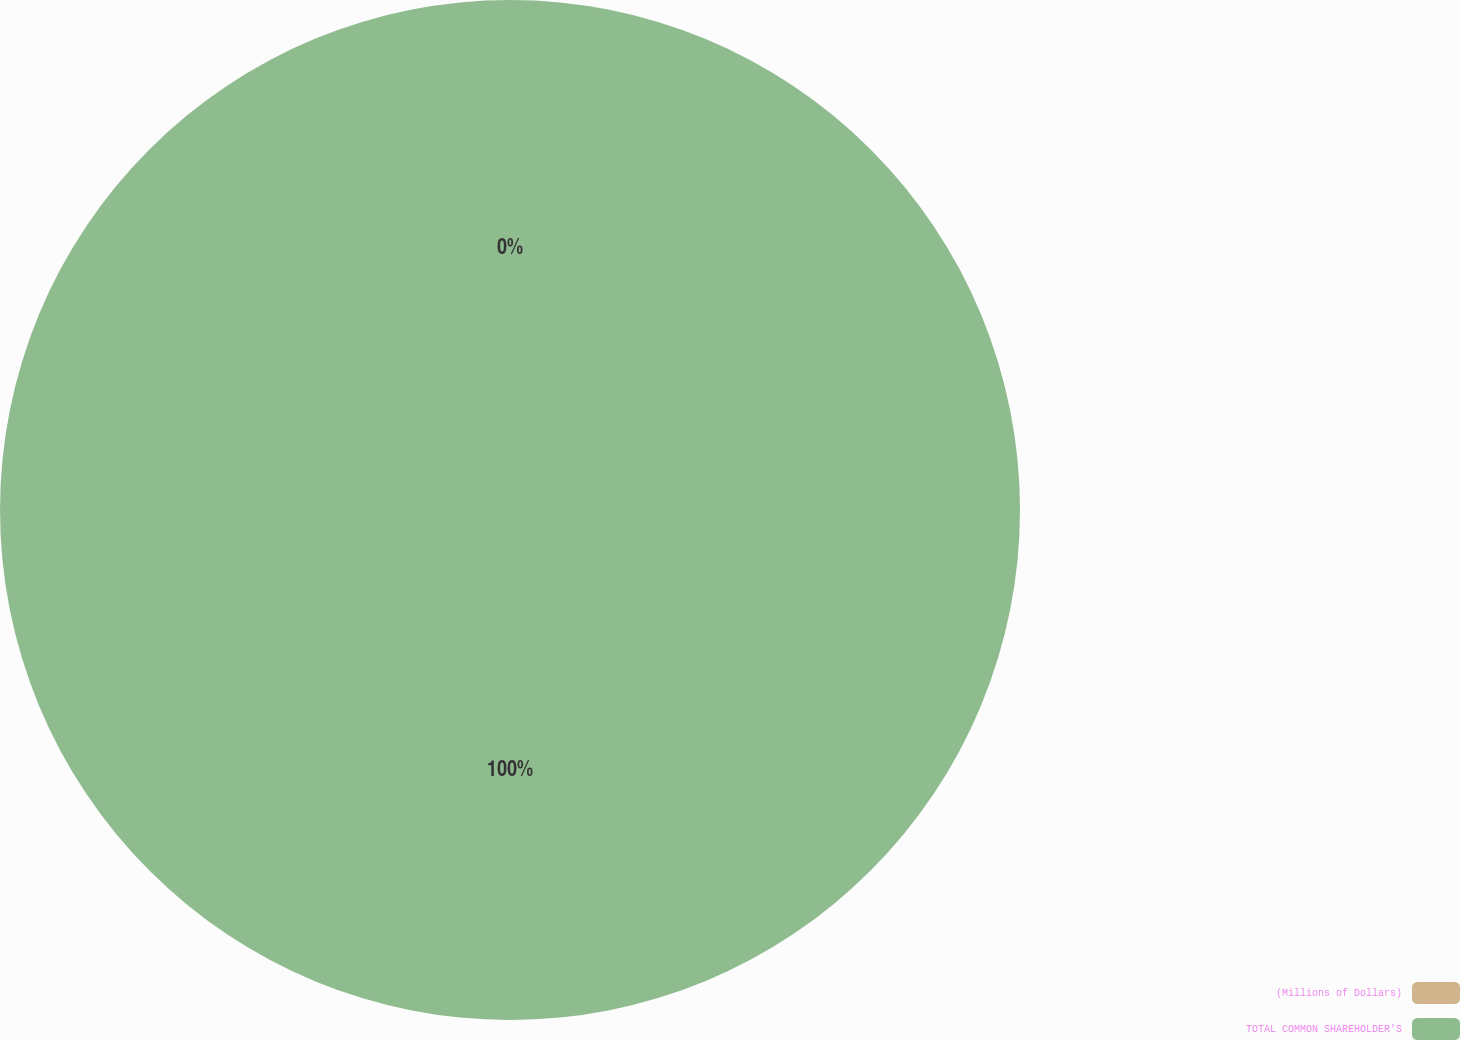<chart> <loc_0><loc_0><loc_500><loc_500><pie_chart><fcel>(Millions of Dollars)<fcel>TOTAL COMMON SHAREHOLDER'S<nl><fcel>0.0%<fcel>100.0%<nl></chart> 